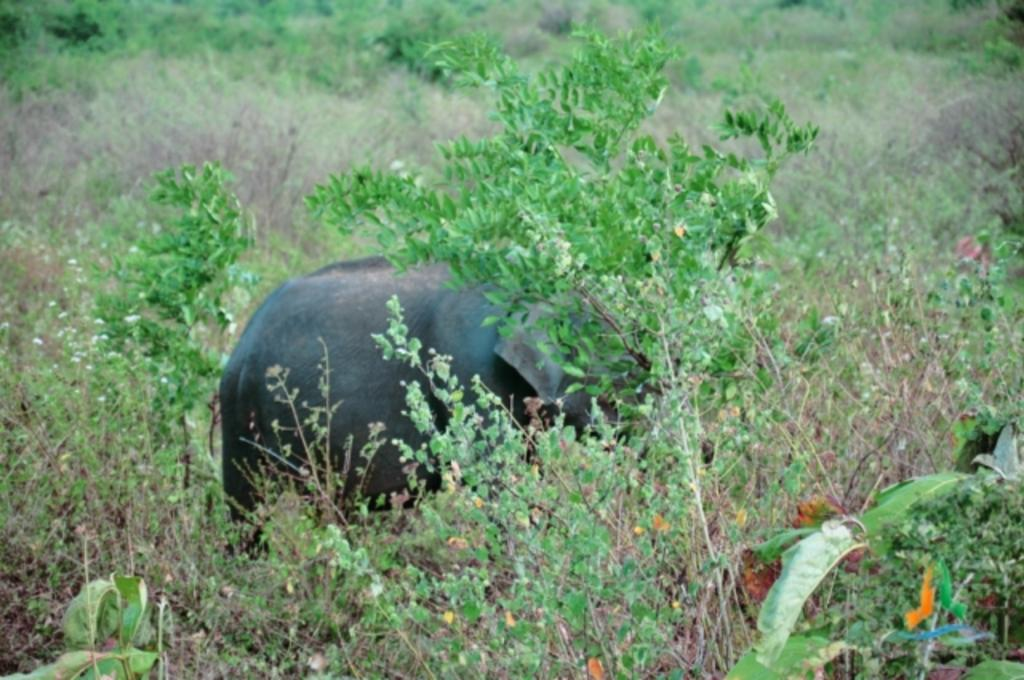What type of living organisms can be seen in the image? Plants can be seen in the image. What animal is present in the image? There is an elephant in the image. Can you describe the position of the elephant in relation to the plants? The elephant is between the plants in the image. What type of baseball support can be seen in the image? There is no baseball or support present in the image; it features plants and an elephant. 